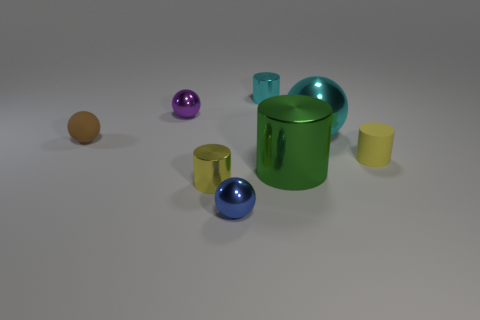Subtract 1 balls. How many balls are left? 3 Subtract all purple cylinders. Subtract all green blocks. How many cylinders are left? 4 Add 2 cyan metallic spheres. How many objects exist? 10 Subtract 0 red cylinders. How many objects are left? 8 Subtract all small brown cubes. Subtract all green cylinders. How many objects are left? 7 Add 2 green metallic cylinders. How many green metallic cylinders are left? 3 Add 5 big cyan spheres. How many big cyan spheres exist? 6 